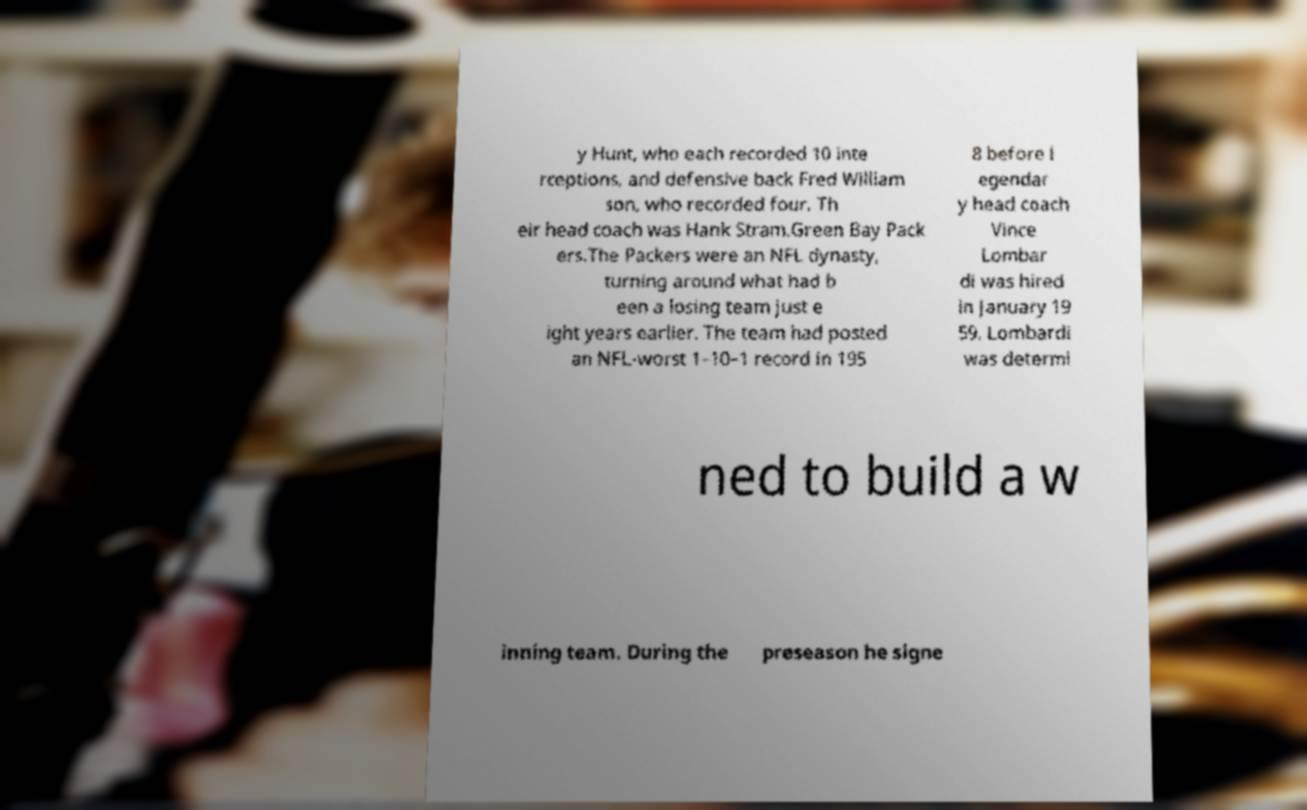Please read and relay the text visible in this image. What does it say? y Hunt, who each recorded 10 inte rceptions, and defensive back Fred William son, who recorded four. Th eir head coach was Hank Stram.Green Bay Pack ers.The Packers were an NFL dynasty, turning around what had b een a losing team just e ight years earlier. The team had posted an NFL-worst 1–10–1 record in 195 8 before l egendar y head coach Vince Lombar di was hired in January 19 59. Lombardi was determi ned to build a w inning team. During the preseason he signe 